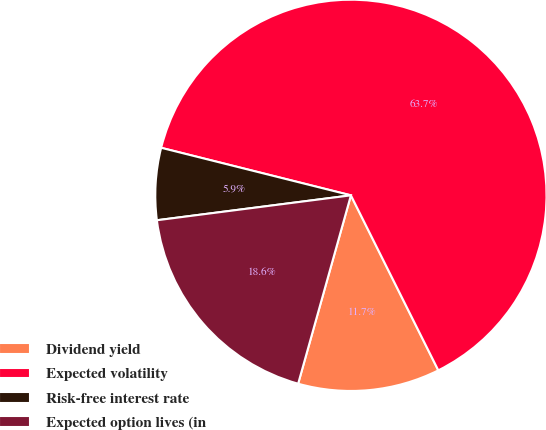Convert chart to OTSL. <chart><loc_0><loc_0><loc_500><loc_500><pie_chart><fcel>Dividend yield<fcel>Expected volatility<fcel>Risk-free interest rate<fcel>Expected option lives (in<nl><fcel>11.72%<fcel>63.72%<fcel>5.94%<fcel>18.62%<nl></chart> 